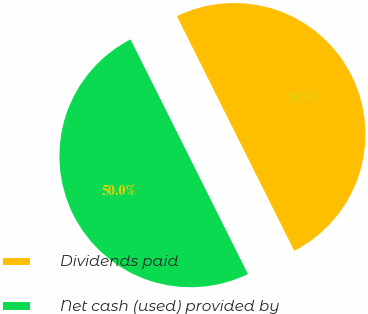Convert chart to OTSL. <chart><loc_0><loc_0><loc_500><loc_500><pie_chart><fcel>Dividends paid<fcel>Net cash (used) provided by<nl><fcel>50.0%<fcel>50.0%<nl></chart> 